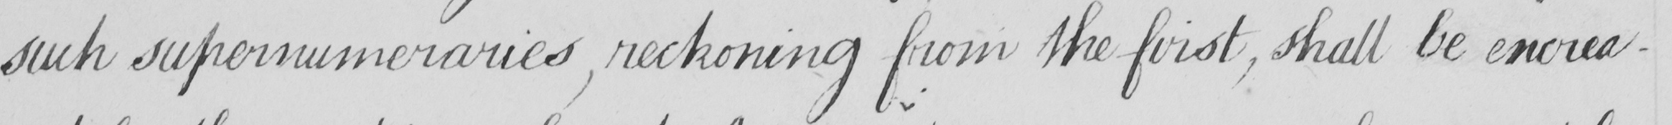What text is written in this handwritten line? such supernumeraries , reckoning from the first , shall be encrea- 